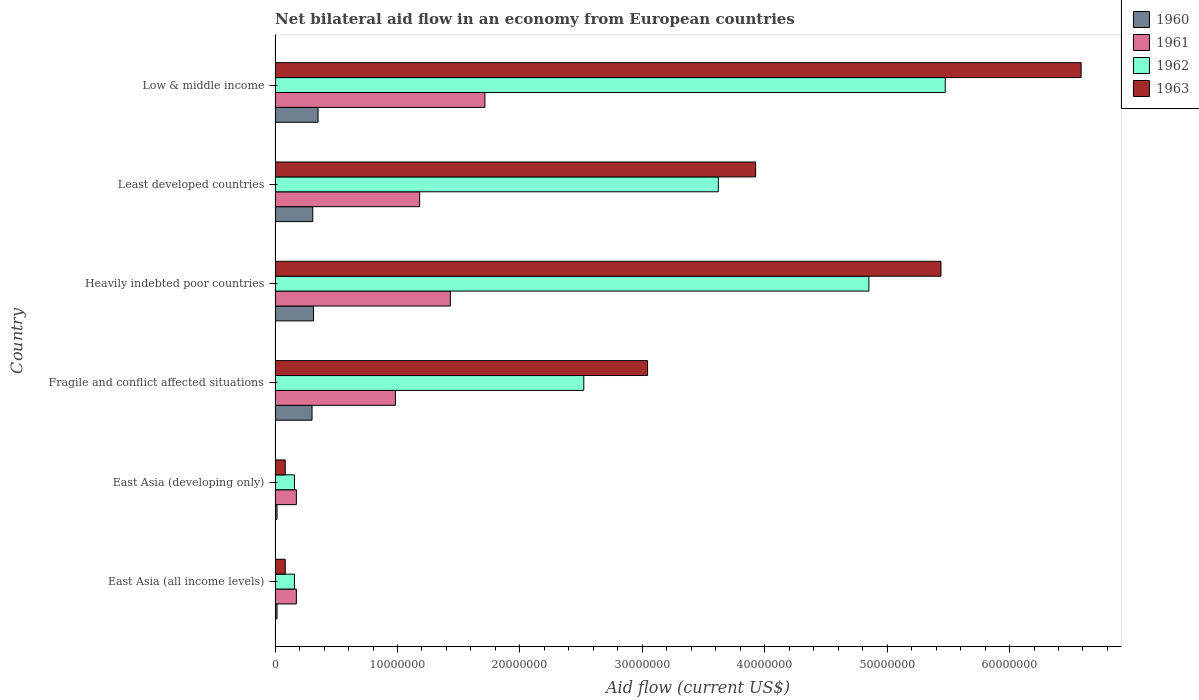How many groups of bars are there?
Your answer should be very brief. 6. Are the number of bars per tick equal to the number of legend labels?
Give a very brief answer. Yes. How many bars are there on the 4th tick from the top?
Ensure brevity in your answer.  4. What is the label of the 5th group of bars from the top?
Offer a very short reply. East Asia (developing only). What is the net bilateral aid flow in 1960 in Heavily indebted poor countries?
Your response must be concise. 3.14e+06. Across all countries, what is the maximum net bilateral aid flow in 1961?
Offer a terse response. 1.71e+07. Across all countries, what is the minimum net bilateral aid flow in 1961?
Make the answer very short. 1.74e+06. In which country was the net bilateral aid flow in 1960 maximum?
Keep it short and to the point. Low & middle income. In which country was the net bilateral aid flow in 1960 minimum?
Give a very brief answer. East Asia (all income levels). What is the total net bilateral aid flow in 1961 in the graph?
Your answer should be compact. 5.66e+07. What is the difference between the net bilateral aid flow in 1960 in Heavily indebted poor countries and the net bilateral aid flow in 1961 in East Asia (all income levels)?
Give a very brief answer. 1.40e+06. What is the average net bilateral aid flow in 1960 per country?
Provide a short and direct response. 2.18e+06. What is the difference between the net bilateral aid flow in 1960 and net bilateral aid flow in 1961 in East Asia (all income levels)?
Your answer should be compact. -1.58e+06. What is the ratio of the net bilateral aid flow in 1960 in Heavily indebted poor countries to that in Least developed countries?
Ensure brevity in your answer.  1.02. What is the difference between the highest and the second highest net bilateral aid flow in 1963?
Make the answer very short. 1.14e+07. What is the difference between the highest and the lowest net bilateral aid flow in 1963?
Your answer should be very brief. 6.50e+07. In how many countries, is the net bilateral aid flow in 1962 greater than the average net bilateral aid flow in 1962 taken over all countries?
Provide a short and direct response. 3. What does the 4th bar from the top in East Asia (all income levels) represents?
Give a very brief answer. 1960. How many bars are there?
Ensure brevity in your answer.  24. What is the difference between two consecutive major ticks on the X-axis?
Your response must be concise. 1.00e+07. Are the values on the major ticks of X-axis written in scientific E-notation?
Keep it short and to the point. No. Where does the legend appear in the graph?
Ensure brevity in your answer.  Top right. How are the legend labels stacked?
Give a very brief answer. Vertical. What is the title of the graph?
Keep it short and to the point. Net bilateral aid flow in an economy from European countries. Does "1970" appear as one of the legend labels in the graph?
Keep it short and to the point. No. What is the Aid flow (current US$) in 1960 in East Asia (all income levels)?
Make the answer very short. 1.60e+05. What is the Aid flow (current US$) of 1961 in East Asia (all income levels)?
Your answer should be compact. 1.74e+06. What is the Aid flow (current US$) in 1962 in East Asia (all income levels)?
Provide a succinct answer. 1.58e+06. What is the Aid flow (current US$) of 1963 in East Asia (all income levels)?
Give a very brief answer. 8.30e+05. What is the Aid flow (current US$) of 1961 in East Asia (developing only)?
Provide a succinct answer. 1.74e+06. What is the Aid flow (current US$) in 1962 in East Asia (developing only)?
Give a very brief answer. 1.58e+06. What is the Aid flow (current US$) in 1963 in East Asia (developing only)?
Offer a terse response. 8.30e+05. What is the Aid flow (current US$) of 1960 in Fragile and conflict affected situations?
Provide a short and direct response. 3.02e+06. What is the Aid flow (current US$) in 1961 in Fragile and conflict affected situations?
Ensure brevity in your answer.  9.83e+06. What is the Aid flow (current US$) in 1962 in Fragile and conflict affected situations?
Make the answer very short. 2.52e+07. What is the Aid flow (current US$) of 1963 in Fragile and conflict affected situations?
Provide a short and direct response. 3.04e+07. What is the Aid flow (current US$) in 1960 in Heavily indebted poor countries?
Your response must be concise. 3.14e+06. What is the Aid flow (current US$) of 1961 in Heavily indebted poor countries?
Your answer should be very brief. 1.43e+07. What is the Aid flow (current US$) of 1962 in Heavily indebted poor countries?
Keep it short and to the point. 4.85e+07. What is the Aid flow (current US$) in 1963 in Heavily indebted poor countries?
Give a very brief answer. 5.44e+07. What is the Aid flow (current US$) of 1960 in Least developed countries?
Keep it short and to the point. 3.08e+06. What is the Aid flow (current US$) of 1961 in Least developed countries?
Provide a short and direct response. 1.18e+07. What is the Aid flow (current US$) of 1962 in Least developed countries?
Provide a succinct answer. 3.62e+07. What is the Aid flow (current US$) of 1963 in Least developed countries?
Offer a terse response. 3.93e+07. What is the Aid flow (current US$) of 1960 in Low & middle income?
Give a very brief answer. 3.51e+06. What is the Aid flow (current US$) of 1961 in Low & middle income?
Offer a terse response. 1.71e+07. What is the Aid flow (current US$) in 1962 in Low & middle income?
Provide a short and direct response. 5.48e+07. What is the Aid flow (current US$) in 1963 in Low & middle income?
Provide a succinct answer. 6.58e+07. Across all countries, what is the maximum Aid flow (current US$) of 1960?
Your response must be concise. 3.51e+06. Across all countries, what is the maximum Aid flow (current US$) of 1961?
Provide a succinct answer. 1.71e+07. Across all countries, what is the maximum Aid flow (current US$) of 1962?
Give a very brief answer. 5.48e+07. Across all countries, what is the maximum Aid flow (current US$) in 1963?
Give a very brief answer. 6.58e+07. Across all countries, what is the minimum Aid flow (current US$) of 1960?
Offer a very short reply. 1.60e+05. Across all countries, what is the minimum Aid flow (current US$) in 1961?
Make the answer very short. 1.74e+06. Across all countries, what is the minimum Aid flow (current US$) in 1962?
Offer a terse response. 1.58e+06. Across all countries, what is the minimum Aid flow (current US$) in 1963?
Offer a terse response. 8.30e+05. What is the total Aid flow (current US$) in 1960 in the graph?
Your response must be concise. 1.31e+07. What is the total Aid flow (current US$) in 1961 in the graph?
Offer a terse response. 5.66e+07. What is the total Aid flow (current US$) of 1962 in the graph?
Provide a short and direct response. 1.68e+08. What is the total Aid flow (current US$) of 1963 in the graph?
Provide a short and direct response. 1.92e+08. What is the difference between the Aid flow (current US$) of 1960 in East Asia (all income levels) and that in East Asia (developing only)?
Offer a very short reply. 0. What is the difference between the Aid flow (current US$) in 1960 in East Asia (all income levels) and that in Fragile and conflict affected situations?
Give a very brief answer. -2.86e+06. What is the difference between the Aid flow (current US$) of 1961 in East Asia (all income levels) and that in Fragile and conflict affected situations?
Your answer should be very brief. -8.09e+06. What is the difference between the Aid flow (current US$) in 1962 in East Asia (all income levels) and that in Fragile and conflict affected situations?
Ensure brevity in your answer.  -2.36e+07. What is the difference between the Aid flow (current US$) in 1963 in East Asia (all income levels) and that in Fragile and conflict affected situations?
Provide a short and direct response. -2.96e+07. What is the difference between the Aid flow (current US$) of 1960 in East Asia (all income levels) and that in Heavily indebted poor countries?
Your response must be concise. -2.98e+06. What is the difference between the Aid flow (current US$) in 1961 in East Asia (all income levels) and that in Heavily indebted poor countries?
Your response must be concise. -1.26e+07. What is the difference between the Aid flow (current US$) of 1962 in East Asia (all income levels) and that in Heavily indebted poor countries?
Ensure brevity in your answer.  -4.69e+07. What is the difference between the Aid flow (current US$) of 1963 in East Asia (all income levels) and that in Heavily indebted poor countries?
Provide a succinct answer. -5.36e+07. What is the difference between the Aid flow (current US$) in 1960 in East Asia (all income levels) and that in Least developed countries?
Provide a succinct answer. -2.92e+06. What is the difference between the Aid flow (current US$) of 1961 in East Asia (all income levels) and that in Least developed countries?
Ensure brevity in your answer.  -1.01e+07. What is the difference between the Aid flow (current US$) in 1962 in East Asia (all income levels) and that in Least developed countries?
Provide a short and direct response. -3.46e+07. What is the difference between the Aid flow (current US$) in 1963 in East Asia (all income levels) and that in Least developed countries?
Your response must be concise. -3.84e+07. What is the difference between the Aid flow (current US$) in 1960 in East Asia (all income levels) and that in Low & middle income?
Make the answer very short. -3.35e+06. What is the difference between the Aid flow (current US$) of 1961 in East Asia (all income levels) and that in Low & middle income?
Give a very brief answer. -1.54e+07. What is the difference between the Aid flow (current US$) of 1962 in East Asia (all income levels) and that in Low & middle income?
Ensure brevity in your answer.  -5.32e+07. What is the difference between the Aid flow (current US$) of 1963 in East Asia (all income levels) and that in Low & middle income?
Give a very brief answer. -6.50e+07. What is the difference between the Aid flow (current US$) in 1960 in East Asia (developing only) and that in Fragile and conflict affected situations?
Ensure brevity in your answer.  -2.86e+06. What is the difference between the Aid flow (current US$) of 1961 in East Asia (developing only) and that in Fragile and conflict affected situations?
Your answer should be compact. -8.09e+06. What is the difference between the Aid flow (current US$) in 1962 in East Asia (developing only) and that in Fragile and conflict affected situations?
Make the answer very short. -2.36e+07. What is the difference between the Aid flow (current US$) in 1963 in East Asia (developing only) and that in Fragile and conflict affected situations?
Give a very brief answer. -2.96e+07. What is the difference between the Aid flow (current US$) of 1960 in East Asia (developing only) and that in Heavily indebted poor countries?
Ensure brevity in your answer.  -2.98e+06. What is the difference between the Aid flow (current US$) in 1961 in East Asia (developing only) and that in Heavily indebted poor countries?
Your answer should be very brief. -1.26e+07. What is the difference between the Aid flow (current US$) in 1962 in East Asia (developing only) and that in Heavily indebted poor countries?
Provide a short and direct response. -4.69e+07. What is the difference between the Aid flow (current US$) of 1963 in East Asia (developing only) and that in Heavily indebted poor countries?
Your answer should be compact. -5.36e+07. What is the difference between the Aid flow (current US$) of 1960 in East Asia (developing only) and that in Least developed countries?
Your response must be concise. -2.92e+06. What is the difference between the Aid flow (current US$) in 1961 in East Asia (developing only) and that in Least developed countries?
Your answer should be compact. -1.01e+07. What is the difference between the Aid flow (current US$) of 1962 in East Asia (developing only) and that in Least developed countries?
Provide a short and direct response. -3.46e+07. What is the difference between the Aid flow (current US$) in 1963 in East Asia (developing only) and that in Least developed countries?
Your answer should be compact. -3.84e+07. What is the difference between the Aid flow (current US$) of 1960 in East Asia (developing only) and that in Low & middle income?
Make the answer very short. -3.35e+06. What is the difference between the Aid flow (current US$) of 1961 in East Asia (developing only) and that in Low & middle income?
Provide a short and direct response. -1.54e+07. What is the difference between the Aid flow (current US$) in 1962 in East Asia (developing only) and that in Low & middle income?
Give a very brief answer. -5.32e+07. What is the difference between the Aid flow (current US$) in 1963 in East Asia (developing only) and that in Low & middle income?
Offer a very short reply. -6.50e+07. What is the difference between the Aid flow (current US$) of 1960 in Fragile and conflict affected situations and that in Heavily indebted poor countries?
Your response must be concise. -1.20e+05. What is the difference between the Aid flow (current US$) of 1961 in Fragile and conflict affected situations and that in Heavily indebted poor countries?
Offer a very short reply. -4.49e+06. What is the difference between the Aid flow (current US$) in 1962 in Fragile and conflict affected situations and that in Heavily indebted poor countries?
Your response must be concise. -2.33e+07. What is the difference between the Aid flow (current US$) of 1963 in Fragile and conflict affected situations and that in Heavily indebted poor countries?
Offer a very short reply. -2.40e+07. What is the difference between the Aid flow (current US$) in 1961 in Fragile and conflict affected situations and that in Least developed countries?
Offer a very short reply. -1.98e+06. What is the difference between the Aid flow (current US$) of 1962 in Fragile and conflict affected situations and that in Least developed countries?
Your answer should be very brief. -1.10e+07. What is the difference between the Aid flow (current US$) in 1963 in Fragile and conflict affected situations and that in Least developed countries?
Give a very brief answer. -8.83e+06. What is the difference between the Aid flow (current US$) in 1960 in Fragile and conflict affected situations and that in Low & middle income?
Keep it short and to the point. -4.90e+05. What is the difference between the Aid flow (current US$) of 1961 in Fragile and conflict affected situations and that in Low & middle income?
Give a very brief answer. -7.31e+06. What is the difference between the Aid flow (current US$) of 1962 in Fragile and conflict affected situations and that in Low & middle income?
Keep it short and to the point. -2.95e+07. What is the difference between the Aid flow (current US$) in 1963 in Fragile and conflict affected situations and that in Low & middle income?
Offer a very short reply. -3.54e+07. What is the difference between the Aid flow (current US$) of 1961 in Heavily indebted poor countries and that in Least developed countries?
Your answer should be compact. 2.51e+06. What is the difference between the Aid flow (current US$) in 1962 in Heavily indebted poor countries and that in Least developed countries?
Offer a very short reply. 1.23e+07. What is the difference between the Aid flow (current US$) of 1963 in Heavily indebted poor countries and that in Least developed countries?
Keep it short and to the point. 1.51e+07. What is the difference between the Aid flow (current US$) in 1960 in Heavily indebted poor countries and that in Low & middle income?
Your answer should be very brief. -3.70e+05. What is the difference between the Aid flow (current US$) in 1961 in Heavily indebted poor countries and that in Low & middle income?
Keep it short and to the point. -2.82e+06. What is the difference between the Aid flow (current US$) in 1962 in Heavily indebted poor countries and that in Low & middle income?
Your response must be concise. -6.24e+06. What is the difference between the Aid flow (current US$) in 1963 in Heavily indebted poor countries and that in Low & middle income?
Your answer should be compact. -1.14e+07. What is the difference between the Aid flow (current US$) in 1960 in Least developed countries and that in Low & middle income?
Your response must be concise. -4.30e+05. What is the difference between the Aid flow (current US$) of 1961 in Least developed countries and that in Low & middle income?
Offer a very short reply. -5.33e+06. What is the difference between the Aid flow (current US$) of 1962 in Least developed countries and that in Low & middle income?
Your answer should be very brief. -1.85e+07. What is the difference between the Aid flow (current US$) of 1963 in Least developed countries and that in Low & middle income?
Your answer should be compact. -2.66e+07. What is the difference between the Aid flow (current US$) of 1960 in East Asia (all income levels) and the Aid flow (current US$) of 1961 in East Asia (developing only)?
Keep it short and to the point. -1.58e+06. What is the difference between the Aid flow (current US$) in 1960 in East Asia (all income levels) and the Aid flow (current US$) in 1962 in East Asia (developing only)?
Offer a very short reply. -1.42e+06. What is the difference between the Aid flow (current US$) in 1960 in East Asia (all income levels) and the Aid flow (current US$) in 1963 in East Asia (developing only)?
Your answer should be very brief. -6.70e+05. What is the difference between the Aid flow (current US$) in 1961 in East Asia (all income levels) and the Aid flow (current US$) in 1963 in East Asia (developing only)?
Your answer should be very brief. 9.10e+05. What is the difference between the Aid flow (current US$) of 1962 in East Asia (all income levels) and the Aid flow (current US$) of 1963 in East Asia (developing only)?
Offer a terse response. 7.50e+05. What is the difference between the Aid flow (current US$) of 1960 in East Asia (all income levels) and the Aid flow (current US$) of 1961 in Fragile and conflict affected situations?
Provide a succinct answer. -9.67e+06. What is the difference between the Aid flow (current US$) of 1960 in East Asia (all income levels) and the Aid flow (current US$) of 1962 in Fragile and conflict affected situations?
Your answer should be compact. -2.51e+07. What is the difference between the Aid flow (current US$) in 1960 in East Asia (all income levels) and the Aid flow (current US$) in 1963 in Fragile and conflict affected situations?
Your response must be concise. -3.03e+07. What is the difference between the Aid flow (current US$) of 1961 in East Asia (all income levels) and the Aid flow (current US$) of 1962 in Fragile and conflict affected situations?
Your response must be concise. -2.35e+07. What is the difference between the Aid flow (current US$) of 1961 in East Asia (all income levels) and the Aid flow (current US$) of 1963 in Fragile and conflict affected situations?
Offer a very short reply. -2.87e+07. What is the difference between the Aid flow (current US$) of 1962 in East Asia (all income levels) and the Aid flow (current US$) of 1963 in Fragile and conflict affected situations?
Provide a succinct answer. -2.88e+07. What is the difference between the Aid flow (current US$) of 1960 in East Asia (all income levels) and the Aid flow (current US$) of 1961 in Heavily indebted poor countries?
Give a very brief answer. -1.42e+07. What is the difference between the Aid flow (current US$) of 1960 in East Asia (all income levels) and the Aid flow (current US$) of 1962 in Heavily indebted poor countries?
Make the answer very short. -4.84e+07. What is the difference between the Aid flow (current US$) in 1960 in East Asia (all income levels) and the Aid flow (current US$) in 1963 in Heavily indebted poor countries?
Your response must be concise. -5.42e+07. What is the difference between the Aid flow (current US$) in 1961 in East Asia (all income levels) and the Aid flow (current US$) in 1962 in Heavily indebted poor countries?
Ensure brevity in your answer.  -4.68e+07. What is the difference between the Aid flow (current US$) in 1961 in East Asia (all income levels) and the Aid flow (current US$) in 1963 in Heavily indebted poor countries?
Offer a terse response. -5.27e+07. What is the difference between the Aid flow (current US$) in 1962 in East Asia (all income levels) and the Aid flow (current US$) in 1963 in Heavily indebted poor countries?
Your response must be concise. -5.28e+07. What is the difference between the Aid flow (current US$) of 1960 in East Asia (all income levels) and the Aid flow (current US$) of 1961 in Least developed countries?
Give a very brief answer. -1.16e+07. What is the difference between the Aid flow (current US$) in 1960 in East Asia (all income levels) and the Aid flow (current US$) in 1962 in Least developed countries?
Offer a very short reply. -3.60e+07. What is the difference between the Aid flow (current US$) in 1960 in East Asia (all income levels) and the Aid flow (current US$) in 1963 in Least developed countries?
Provide a short and direct response. -3.91e+07. What is the difference between the Aid flow (current US$) in 1961 in East Asia (all income levels) and the Aid flow (current US$) in 1962 in Least developed countries?
Offer a very short reply. -3.45e+07. What is the difference between the Aid flow (current US$) of 1961 in East Asia (all income levels) and the Aid flow (current US$) of 1963 in Least developed countries?
Keep it short and to the point. -3.75e+07. What is the difference between the Aid flow (current US$) in 1962 in East Asia (all income levels) and the Aid flow (current US$) in 1963 in Least developed countries?
Provide a short and direct response. -3.77e+07. What is the difference between the Aid flow (current US$) in 1960 in East Asia (all income levels) and the Aid flow (current US$) in 1961 in Low & middle income?
Offer a terse response. -1.70e+07. What is the difference between the Aid flow (current US$) in 1960 in East Asia (all income levels) and the Aid flow (current US$) in 1962 in Low & middle income?
Offer a terse response. -5.46e+07. What is the difference between the Aid flow (current US$) of 1960 in East Asia (all income levels) and the Aid flow (current US$) of 1963 in Low & middle income?
Your response must be concise. -6.57e+07. What is the difference between the Aid flow (current US$) in 1961 in East Asia (all income levels) and the Aid flow (current US$) in 1962 in Low & middle income?
Make the answer very short. -5.30e+07. What is the difference between the Aid flow (current US$) of 1961 in East Asia (all income levels) and the Aid flow (current US$) of 1963 in Low & middle income?
Make the answer very short. -6.41e+07. What is the difference between the Aid flow (current US$) of 1962 in East Asia (all income levels) and the Aid flow (current US$) of 1963 in Low & middle income?
Offer a very short reply. -6.43e+07. What is the difference between the Aid flow (current US$) in 1960 in East Asia (developing only) and the Aid flow (current US$) in 1961 in Fragile and conflict affected situations?
Offer a very short reply. -9.67e+06. What is the difference between the Aid flow (current US$) of 1960 in East Asia (developing only) and the Aid flow (current US$) of 1962 in Fragile and conflict affected situations?
Provide a succinct answer. -2.51e+07. What is the difference between the Aid flow (current US$) of 1960 in East Asia (developing only) and the Aid flow (current US$) of 1963 in Fragile and conflict affected situations?
Provide a short and direct response. -3.03e+07. What is the difference between the Aid flow (current US$) of 1961 in East Asia (developing only) and the Aid flow (current US$) of 1962 in Fragile and conflict affected situations?
Provide a short and direct response. -2.35e+07. What is the difference between the Aid flow (current US$) of 1961 in East Asia (developing only) and the Aid flow (current US$) of 1963 in Fragile and conflict affected situations?
Provide a short and direct response. -2.87e+07. What is the difference between the Aid flow (current US$) in 1962 in East Asia (developing only) and the Aid flow (current US$) in 1963 in Fragile and conflict affected situations?
Your answer should be compact. -2.88e+07. What is the difference between the Aid flow (current US$) in 1960 in East Asia (developing only) and the Aid flow (current US$) in 1961 in Heavily indebted poor countries?
Make the answer very short. -1.42e+07. What is the difference between the Aid flow (current US$) in 1960 in East Asia (developing only) and the Aid flow (current US$) in 1962 in Heavily indebted poor countries?
Your response must be concise. -4.84e+07. What is the difference between the Aid flow (current US$) in 1960 in East Asia (developing only) and the Aid flow (current US$) in 1963 in Heavily indebted poor countries?
Make the answer very short. -5.42e+07. What is the difference between the Aid flow (current US$) in 1961 in East Asia (developing only) and the Aid flow (current US$) in 1962 in Heavily indebted poor countries?
Your answer should be compact. -4.68e+07. What is the difference between the Aid flow (current US$) in 1961 in East Asia (developing only) and the Aid flow (current US$) in 1963 in Heavily indebted poor countries?
Offer a very short reply. -5.27e+07. What is the difference between the Aid flow (current US$) in 1962 in East Asia (developing only) and the Aid flow (current US$) in 1963 in Heavily indebted poor countries?
Your answer should be compact. -5.28e+07. What is the difference between the Aid flow (current US$) of 1960 in East Asia (developing only) and the Aid flow (current US$) of 1961 in Least developed countries?
Your answer should be compact. -1.16e+07. What is the difference between the Aid flow (current US$) of 1960 in East Asia (developing only) and the Aid flow (current US$) of 1962 in Least developed countries?
Make the answer very short. -3.60e+07. What is the difference between the Aid flow (current US$) of 1960 in East Asia (developing only) and the Aid flow (current US$) of 1963 in Least developed countries?
Your answer should be very brief. -3.91e+07. What is the difference between the Aid flow (current US$) of 1961 in East Asia (developing only) and the Aid flow (current US$) of 1962 in Least developed countries?
Offer a terse response. -3.45e+07. What is the difference between the Aid flow (current US$) in 1961 in East Asia (developing only) and the Aid flow (current US$) in 1963 in Least developed countries?
Ensure brevity in your answer.  -3.75e+07. What is the difference between the Aid flow (current US$) of 1962 in East Asia (developing only) and the Aid flow (current US$) of 1963 in Least developed countries?
Offer a very short reply. -3.77e+07. What is the difference between the Aid flow (current US$) in 1960 in East Asia (developing only) and the Aid flow (current US$) in 1961 in Low & middle income?
Provide a short and direct response. -1.70e+07. What is the difference between the Aid flow (current US$) of 1960 in East Asia (developing only) and the Aid flow (current US$) of 1962 in Low & middle income?
Keep it short and to the point. -5.46e+07. What is the difference between the Aid flow (current US$) in 1960 in East Asia (developing only) and the Aid flow (current US$) in 1963 in Low & middle income?
Your answer should be compact. -6.57e+07. What is the difference between the Aid flow (current US$) in 1961 in East Asia (developing only) and the Aid flow (current US$) in 1962 in Low & middle income?
Your answer should be compact. -5.30e+07. What is the difference between the Aid flow (current US$) in 1961 in East Asia (developing only) and the Aid flow (current US$) in 1963 in Low & middle income?
Your answer should be very brief. -6.41e+07. What is the difference between the Aid flow (current US$) of 1962 in East Asia (developing only) and the Aid flow (current US$) of 1963 in Low & middle income?
Provide a short and direct response. -6.43e+07. What is the difference between the Aid flow (current US$) of 1960 in Fragile and conflict affected situations and the Aid flow (current US$) of 1961 in Heavily indebted poor countries?
Provide a short and direct response. -1.13e+07. What is the difference between the Aid flow (current US$) of 1960 in Fragile and conflict affected situations and the Aid flow (current US$) of 1962 in Heavily indebted poor countries?
Your answer should be very brief. -4.55e+07. What is the difference between the Aid flow (current US$) of 1960 in Fragile and conflict affected situations and the Aid flow (current US$) of 1963 in Heavily indebted poor countries?
Your answer should be compact. -5.14e+07. What is the difference between the Aid flow (current US$) of 1961 in Fragile and conflict affected situations and the Aid flow (current US$) of 1962 in Heavily indebted poor countries?
Your answer should be compact. -3.87e+07. What is the difference between the Aid flow (current US$) in 1961 in Fragile and conflict affected situations and the Aid flow (current US$) in 1963 in Heavily indebted poor countries?
Give a very brief answer. -4.46e+07. What is the difference between the Aid flow (current US$) in 1962 in Fragile and conflict affected situations and the Aid flow (current US$) in 1963 in Heavily indebted poor countries?
Offer a very short reply. -2.92e+07. What is the difference between the Aid flow (current US$) of 1960 in Fragile and conflict affected situations and the Aid flow (current US$) of 1961 in Least developed countries?
Ensure brevity in your answer.  -8.79e+06. What is the difference between the Aid flow (current US$) in 1960 in Fragile and conflict affected situations and the Aid flow (current US$) in 1962 in Least developed countries?
Your response must be concise. -3.32e+07. What is the difference between the Aid flow (current US$) of 1960 in Fragile and conflict affected situations and the Aid flow (current US$) of 1963 in Least developed countries?
Make the answer very short. -3.62e+07. What is the difference between the Aid flow (current US$) in 1961 in Fragile and conflict affected situations and the Aid flow (current US$) in 1962 in Least developed countries?
Offer a terse response. -2.64e+07. What is the difference between the Aid flow (current US$) in 1961 in Fragile and conflict affected situations and the Aid flow (current US$) in 1963 in Least developed countries?
Give a very brief answer. -2.94e+07. What is the difference between the Aid flow (current US$) of 1962 in Fragile and conflict affected situations and the Aid flow (current US$) of 1963 in Least developed countries?
Give a very brief answer. -1.40e+07. What is the difference between the Aid flow (current US$) of 1960 in Fragile and conflict affected situations and the Aid flow (current US$) of 1961 in Low & middle income?
Your response must be concise. -1.41e+07. What is the difference between the Aid flow (current US$) in 1960 in Fragile and conflict affected situations and the Aid flow (current US$) in 1962 in Low & middle income?
Your answer should be very brief. -5.17e+07. What is the difference between the Aid flow (current US$) of 1960 in Fragile and conflict affected situations and the Aid flow (current US$) of 1963 in Low & middle income?
Keep it short and to the point. -6.28e+07. What is the difference between the Aid flow (current US$) in 1961 in Fragile and conflict affected situations and the Aid flow (current US$) in 1962 in Low & middle income?
Offer a very short reply. -4.49e+07. What is the difference between the Aid flow (current US$) of 1961 in Fragile and conflict affected situations and the Aid flow (current US$) of 1963 in Low & middle income?
Offer a terse response. -5.60e+07. What is the difference between the Aid flow (current US$) in 1962 in Fragile and conflict affected situations and the Aid flow (current US$) in 1963 in Low & middle income?
Provide a succinct answer. -4.06e+07. What is the difference between the Aid flow (current US$) in 1960 in Heavily indebted poor countries and the Aid flow (current US$) in 1961 in Least developed countries?
Offer a very short reply. -8.67e+06. What is the difference between the Aid flow (current US$) in 1960 in Heavily indebted poor countries and the Aid flow (current US$) in 1962 in Least developed countries?
Offer a very short reply. -3.31e+07. What is the difference between the Aid flow (current US$) in 1960 in Heavily indebted poor countries and the Aid flow (current US$) in 1963 in Least developed countries?
Offer a terse response. -3.61e+07. What is the difference between the Aid flow (current US$) in 1961 in Heavily indebted poor countries and the Aid flow (current US$) in 1962 in Least developed countries?
Offer a very short reply. -2.19e+07. What is the difference between the Aid flow (current US$) of 1961 in Heavily indebted poor countries and the Aid flow (current US$) of 1963 in Least developed countries?
Your answer should be very brief. -2.49e+07. What is the difference between the Aid flow (current US$) in 1962 in Heavily indebted poor countries and the Aid flow (current US$) in 1963 in Least developed countries?
Keep it short and to the point. 9.25e+06. What is the difference between the Aid flow (current US$) in 1960 in Heavily indebted poor countries and the Aid flow (current US$) in 1961 in Low & middle income?
Provide a short and direct response. -1.40e+07. What is the difference between the Aid flow (current US$) of 1960 in Heavily indebted poor countries and the Aid flow (current US$) of 1962 in Low & middle income?
Give a very brief answer. -5.16e+07. What is the difference between the Aid flow (current US$) of 1960 in Heavily indebted poor countries and the Aid flow (current US$) of 1963 in Low & middle income?
Provide a short and direct response. -6.27e+07. What is the difference between the Aid flow (current US$) in 1961 in Heavily indebted poor countries and the Aid flow (current US$) in 1962 in Low & middle income?
Ensure brevity in your answer.  -4.04e+07. What is the difference between the Aid flow (current US$) in 1961 in Heavily indebted poor countries and the Aid flow (current US$) in 1963 in Low & middle income?
Ensure brevity in your answer.  -5.15e+07. What is the difference between the Aid flow (current US$) of 1962 in Heavily indebted poor countries and the Aid flow (current US$) of 1963 in Low & middle income?
Provide a short and direct response. -1.73e+07. What is the difference between the Aid flow (current US$) in 1960 in Least developed countries and the Aid flow (current US$) in 1961 in Low & middle income?
Your response must be concise. -1.41e+07. What is the difference between the Aid flow (current US$) in 1960 in Least developed countries and the Aid flow (current US$) in 1962 in Low & middle income?
Provide a succinct answer. -5.17e+07. What is the difference between the Aid flow (current US$) of 1960 in Least developed countries and the Aid flow (current US$) of 1963 in Low & middle income?
Provide a short and direct response. -6.28e+07. What is the difference between the Aid flow (current US$) in 1961 in Least developed countries and the Aid flow (current US$) in 1962 in Low & middle income?
Offer a very short reply. -4.29e+07. What is the difference between the Aid flow (current US$) in 1961 in Least developed countries and the Aid flow (current US$) in 1963 in Low & middle income?
Provide a succinct answer. -5.40e+07. What is the difference between the Aid flow (current US$) in 1962 in Least developed countries and the Aid flow (current US$) in 1963 in Low & middle income?
Give a very brief answer. -2.96e+07. What is the average Aid flow (current US$) in 1960 per country?
Keep it short and to the point. 2.18e+06. What is the average Aid flow (current US$) of 1961 per country?
Provide a short and direct response. 9.43e+06. What is the average Aid flow (current US$) in 1962 per country?
Keep it short and to the point. 2.80e+07. What is the average Aid flow (current US$) of 1963 per country?
Your response must be concise. 3.19e+07. What is the difference between the Aid flow (current US$) in 1960 and Aid flow (current US$) in 1961 in East Asia (all income levels)?
Give a very brief answer. -1.58e+06. What is the difference between the Aid flow (current US$) in 1960 and Aid flow (current US$) in 1962 in East Asia (all income levels)?
Make the answer very short. -1.42e+06. What is the difference between the Aid flow (current US$) in 1960 and Aid flow (current US$) in 1963 in East Asia (all income levels)?
Ensure brevity in your answer.  -6.70e+05. What is the difference between the Aid flow (current US$) of 1961 and Aid flow (current US$) of 1963 in East Asia (all income levels)?
Your response must be concise. 9.10e+05. What is the difference between the Aid flow (current US$) in 1962 and Aid flow (current US$) in 1963 in East Asia (all income levels)?
Your answer should be very brief. 7.50e+05. What is the difference between the Aid flow (current US$) in 1960 and Aid flow (current US$) in 1961 in East Asia (developing only)?
Provide a succinct answer. -1.58e+06. What is the difference between the Aid flow (current US$) in 1960 and Aid flow (current US$) in 1962 in East Asia (developing only)?
Your answer should be very brief. -1.42e+06. What is the difference between the Aid flow (current US$) of 1960 and Aid flow (current US$) of 1963 in East Asia (developing only)?
Keep it short and to the point. -6.70e+05. What is the difference between the Aid flow (current US$) of 1961 and Aid flow (current US$) of 1963 in East Asia (developing only)?
Your response must be concise. 9.10e+05. What is the difference between the Aid flow (current US$) of 1962 and Aid flow (current US$) of 1963 in East Asia (developing only)?
Give a very brief answer. 7.50e+05. What is the difference between the Aid flow (current US$) in 1960 and Aid flow (current US$) in 1961 in Fragile and conflict affected situations?
Offer a terse response. -6.81e+06. What is the difference between the Aid flow (current US$) in 1960 and Aid flow (current US$) in 1962 in Fragile and conflict affected situations?
Ensure brevity in your answer.  -2.22e+07. What is the difference between the Aid flow (current US$) in 1960 and Aid flow (current US$) in 1963 in Fragile and conflict affected situations?
Offer a terse response. -2.74e+07. What is the difference between the Aid flow (current US$) of 1961 and Aid flow (current US$) of 1962 in Fragile and conflict affected situations?
Offer a terse response. -1.54e+07. What is the difference between the Aid flow (current US$) in 1961 and Aid flow (current US$) in 1963 in Fragile and conflict affected situations?
Give a very brief answer. -2.06e+07. What is the difference between the Aid flow (current US$) of 1962 and Aid flow (current US$) of 1963 in Fragile and conflict affected situations?
Offer a terse response. -5.21e+06. What is the difference between the Aid flow (current US$) in 1960 and Aid flow (current US$) in 1961 in Heavily indebted poor countries?
Keep it short and to the point. -1.12e+07. What is the difference between the Aid flow (current US$) of 1960 and Aid flow (current US$) of 1962 in Heavily indebted poor countries?
Offer a very short reply. -4.54e+07. What is the difference between the Aid flow (current US$) in 1960 and Aid flow (current US$) in 1963 in Heavily indebted poor countries?
Offer a terse response. -5.13e+07. What is the difference between the Aid flow (current US$) in 1961 and Aid flow (current US$) in 1962 in Heavily indebted poor countries?
Your answer should be very brief. -3.42e+07. What is the difference between the Aid flow (current US$) of 1961 and Aid flow (current US$) of 1963 in Heavily indebted poor countries?
Provide a succinct answer. -4.01e+07. What is the difference between the Aid flow (current US$) in 1962 and Aid flow (current US$) in 1963 in Heavily indebted poor countries?
Your answer should be compact. -5.89e+06. What is the difference between the Aid flow (current US$) of 1960 and Aid flow (current US$) of 1961 in Least developed countries?
Ensure brevity in your answer.  -8.73e+06. What is the difference between the Aid flow (current US$) of 1960 and Aid flow (current US$) of 1962 in Least developed countries?
Offer a very short reply. -3.31e+07. What is the difference between the Aid flow (current US$) of 1960 and Aid flow (current US$) of 1963 in Least developed countries?
Keep it short and to the point. -3.62e+07. What is the difference between the Aid flow (current US$) in 1961 and Aid flow (current US$) in 1962 in Least developed countries?
Give a very brief answer. -2.44e+07. What is the difference between the Aid flow (current US$) in 1961 and Aid flow (current US$) in 1963 in Least developed countries?
Ensure brevity in your answer.  -2.74e+07. What is the difference between the Aid flow (current US$) of 1962 and Aid flow (current US$) of 1963 in Least developed countries?
Make the answer very short. -3.05e+06. What is the difference between the Aid flow (current US$) of 1960 and Aid flow (current US$) of 1961 in Low & middle income?
Provide a succinct answer. -1.36e+07. What is the difference between the Aid flow (current US$) in 1960 and Aid flow (current US$) in 1962 in Low & middle income?
Provide a short and direct response. -5.12e+07. What is the difference between the Aid flow (current US$) of 1960 and Aid flow (current US$) of 1963 in Low & middle income?
Ensure brevity in your answer.  -6.23e+07. What is the difference between the Aid flow (current US$) of 1961 and Aid flow (current US$) of 1962 in Low & middle income?
Your answer should be very brief. -3.76e+07. What is the difference between the Aid flow (current US$) of 1961 and Aid flow (current US$) of 1963 in Low & middle income?
Keep it short and to the point. -4.87e+07. What is the difference between the Aid flow (current US$) of 1962 and Aid flow (current US$) of 1963 in Low & middle income?
Make the answer very short. -1.11e+07. What is the ratio of the Aid flow (current US$) in 1960 in East Asia (all income levels) to that in East Asia (developing only)?
Your response must be concise. 1. What is the ratio of the Aid flow (current US$) in 1961 in East Asia (all income levels) to that in East Asia (developing only)?
Ensure brevity in your answer.  1. What is the ratio of the Aid flow (current US$) in 1963 in East Asia (all income levels) to that in East Asia (developing only)?
Provide a succinct answer. 1. What is the ratio of the Aid flow (current US$) of 1960 in East Asia (all income levels) to that in Fragile and conflict affected situations?
Your answer should be very brief. 0.05. What is the ratio of the Aid flow (current US$) in 1961 in East Asia (all income levels) to that in Fragile and conflict affected situations?
Provide a succinct answer. 0.18. What is the ratio of the Aid flow (current US$) of 1962 in East Asia (all income levels) to that in Fragile and conflict affected situations?
Give a very brief answer. 0.06. What is the ratio of the Aid flow (current US$) of 1963 in East Asia (all income levels) to that in Fragile and conflict affected situations?
Offer a terse response. 0.03. What is the ratio of the Aid flow (current US$) in 1960 in East Asia (all income levels) to that in Heavily indebted poor countries?
Ensure brevity in your answer.  0.05. What is the ratio of the Aid flow (current US$) in 1961 in East Asia (all income levels) to that in Heavily indebted poor countries?
Your response must be concise. 0.12. What is the ratio of the Aid flow (current US$) of 1962 in East Asia (all income levels) to that in Heavily indebted poor countries?
Your response must be concise. 0.03. What is the ratio of the Aid flow (current US$) of 1963 in East Asia (all income levels) to that in Heavily indebted poor countries?
Your answer should be compact. 0.02. What is the ratio of the Aid flow (current US$) in 1960 in East Asia (all income levels) to that in Least developed countries?
Your answer should be compact. 0.05. What is the ratio of the Aid flow (current US$) in 1961 in East Asia (all income levels) to that in Least developed countries?
Offer a terse response. 0.15. What is the ratio of the Aid flow (current US$) of 1962 in East Asia (all income levels) to that in Least developed countries?
Offer a terse response. 0.04. What is the ratio of the Aid flow (current US$) of 1963 in East Asia (all income levels) to that in Least developed countries?
Your answer should be very brief. 0.02. What is the ratio of the Aid flow (current US$) of 1960 in East Asia (all income levels) to that in Low & middle income?
Give a very brief answer. 0.05. What is the ratio of the Aid flow (current US$) of 1961 in East Asia (all income levels) to that in Low & middle income?
Offer a terse response. 0.1. What is the ratio of the Aid flow (current US$) of 1962 in East Asia (all income levels) to that in Low & middle income?
Keep it short and to the point. 0.03. What is the ratio of the Aid flow (current US$) in 1963 in East Asia (all income levels) to that in Low & middle income?
Make the answer very short. 0.01. What is the ratio of the Aid flow (current US$) in 1960 in East Asia (developing only) to that in Fragile and conflict affected situations?
Ensure brevity in your answer.  0.05. What is the ratio of the Aid flow (current US$) of 1961 in East Asia (developing only) to that in Fragile and conflict affected situations?
Your answer should be very brief. 0.18. What is the ratio of the Aid flow (current US$) in 1962 in East Asia (developing only) to that in Fragile and conflict affected situations?
Your answer should be very brief. 0.06. What is the ratio of the Aid flow (current US$) of 1963 in East Asia (developing only) to that in Fragile and conflict affected situations?
Your answer should be very brief. 0.03. What is the ratio of the Aid flow (current US$) in 1960 in East Asia (developing only) to that in Heavily indebted poor countries?
Offer a terse response. 0.05. What is the ratio of the Aid flow (current US$) in 1961 in East Asia (developing only) to that in Heavily indebted poor countries?
Provide a succinct answer. 0.12. What is the ratio of the Aid flow (current US$) in 1962 in East Asia (developing only) to that in Heavily indebted poor countries?
Keep it short and to the point. 0.03. What is the ratio of the Aid flow (current US$) of 1963 in East Asia (developing only) to that in Heavily indebted poor countries?
Provide a succinct answer. 0.02. What is the ratio of the Aid flow (current US$) in 1960 in East Asia (developing only) to that in Least developed countries?
Provide a short and direct response. 0.05. What is the ratio of the Aid flow (current US$) in 1961 in East Asia (developing only) to that in Least developed countries?
Make the answer very short. 0.15. What is the ratio of the Aid flow (current US$) of 1962 in East Asia (developing only) to that in Least developed countries?
Make the answer very short. 0.04. What is the ratio of the Aid flow (current US$) in 1963 in East Asia (developing only) to that in Least developed countries?
Offer a very short reply. 0.02. What is the ratio of the Aid flow (current US$) in 1960 in East Asia (developing only) to that in Low & middle income?
Offer a very short reply. 0.05. What is the ratio of the Aid flow (current US$) of 1961 in East Asia (developing only) to that in Low & middle income?
Give a very brief answer. 0.1. What is the ratio of the Aid flow (current US$) of 1962 in East Asia (developing only) to that in Low & middle income?
Your answer should be very brief. 0.03. What is the ratio of the Aid flow (current US$) of 1963 in East Asia (developing only) to that in Low & middle income?
Your response must be concise. 0.01. What is the ratio of the Aid flow (current US$) of 1960 in Fragile and conflict affected situations to that in Heavily indebted poor countries?
Make the answer very short. 0.96. What is the ratio of the Aid flow (current US$) in 1961 in Fragile and conflict affected situations to that in Heavily indebted poor countries?
Offer a terse response. 0.69. What is the ratio of the Aid flow (current US$) in 1962 in Fragile and conflict affected situations to that in Heavily indebted poor countries?
Give a very brief answer. 0.52. What is the ratio of the Aid flow (current US$) in 1963 in Fragile and conflict affected situations to that in Heavily indebted poor countries?
Your answer should be compact. 0.56. What is the ratio of the Aid flow (current US$) in 1960 in Fragile and conflict affected situations to that in Least developed countries?
Provide a succinct answer. 0.98. What is the ratio of the Aid flow (current US$) of 1961 in Fragile and conflict affected situations to that in Least developed countries?
Provide a succinct answer. 0.83. What is the ratio of the Aid flow (current US$) of 1962 in Fragile and conflict affected situations to that in Least developed countries?
Your response must be concise. 0.7. What is the ratio of the Aid flow (current US$) in 1963 in Fragile and conflict affected situations to that in Least developed countries?
Offer a terse response. 0.78. What is the ratio of the Aid flow (current US$) in 1960 in Fragile and conflict affected situations to that in Low & middle income?
Offer a very short reply. 0.86. What is the ratio of the Aid flow (current US$) of 1961 in Fragile and conflict affected situations to that in Low & middle income?
Keep it short and to the point. 0.57. What is the ratio of the Aid flow (current US$) of 1962 in Fragile and conflict affected situations to that in Low & middle income?
Your answer should be very brief. 0.46. What is the ratio of the Aid flow (current US$) in 1963 in Fragile and conflict affected situations to that in Low & middle income?
Provide a short and direct response. 0.46. What is the ratio of the Aid flow (current US$) of 1960 in Heavily indebted poor countries to that in Least developed countries?
Provide a succinct answer. 1.02. What is the ratio of the Aid flow (current US$) of 1961 in Heavily indebted poor countries to that in Least developed countries?
Your answer should be compact. 1.21. What is the ratio of the Aid flow (current US$) in 1962 in Heavily indebted poor countries to that in Least developed countries?
Ensure brevity in your answer.  1.34. What is the ratio of the Aid flow (current US$) in 1963 in Heavily indebted poor countries to that in Least developed countries?
Provide a short and direct response. 1.39. What is the ratio of the Aid flow (current US$) in 1960 in Heavily indebted poor countries to that in Low & middle income?
Make the answer very short. 0.89. What is the ratio of the Aid flow (current US$) in 1961 in Heavily indebted poor countries to that in Low & middle income?
Ensure brevity in your answer.  0.84. What is the ratio of the Aid flow (current US$) of 1962 in Heavily indebted poor countries to that in Low & middle income?
Keep it short and to the point. 0.89. What is the ratio of the Aid flow (current US$) in 1963 in Heavily indebted poor countries to that in Low & middle income?
Make the answer very short. 0.83. What is the ratio of the Aid flow (current US$) of 1960 in Least developed countries to that in Low & middle income?
Offer a very short reply. 0.88. What is the ratio of the Aid flow (current US$) in 1961 in Least developed countries to that in Low & middle income?
Offer a terse response. 0.69. What is the ratio of the Aid flow (current US$) of 1962 in Least developed countries to that in Low & middle income?
Provide a succinct answer. 0.66. What is the ratio of the Aid flow (current US$) of 1963 in Least developed countries to that in Low & middle income?
Your answer should be compact. 0.6. What is the difference between the highest and the second highest Aid flow (current US$) in 1960?
Offer a terse response. 3.70e+05. What is the difference between the highest and the second highest Aid flow (current US$) in 1961?
Ensure brevity in your answer.  2.82e+06. What is the difference between the highest and the second highest Aid flow (current US$) in 1962?
Offer a very short reply. 6.24e+06. What is the difference between the highest and the second highest Aid flow (current US$) of 1963?
Your response must be concise. 1.14e+07. What is the difference between the highest and the lowest Aid flow (current US$) in 1960?
Provide a succinct answer. 3.35e+06. What is the difference between the highest and the lowest Aid flow (current US$) of 1961?
Your answer should be compact. 1.54e+07. What is the difference between the highest and the lowest Aid flow (current US$) of 1962?
Your answer should be compact. 5.32e+07. What is the difference between the highest and the lowest Aid flow (current US$) in 1963?
Provide a succinct answer. 6.50e+07. 